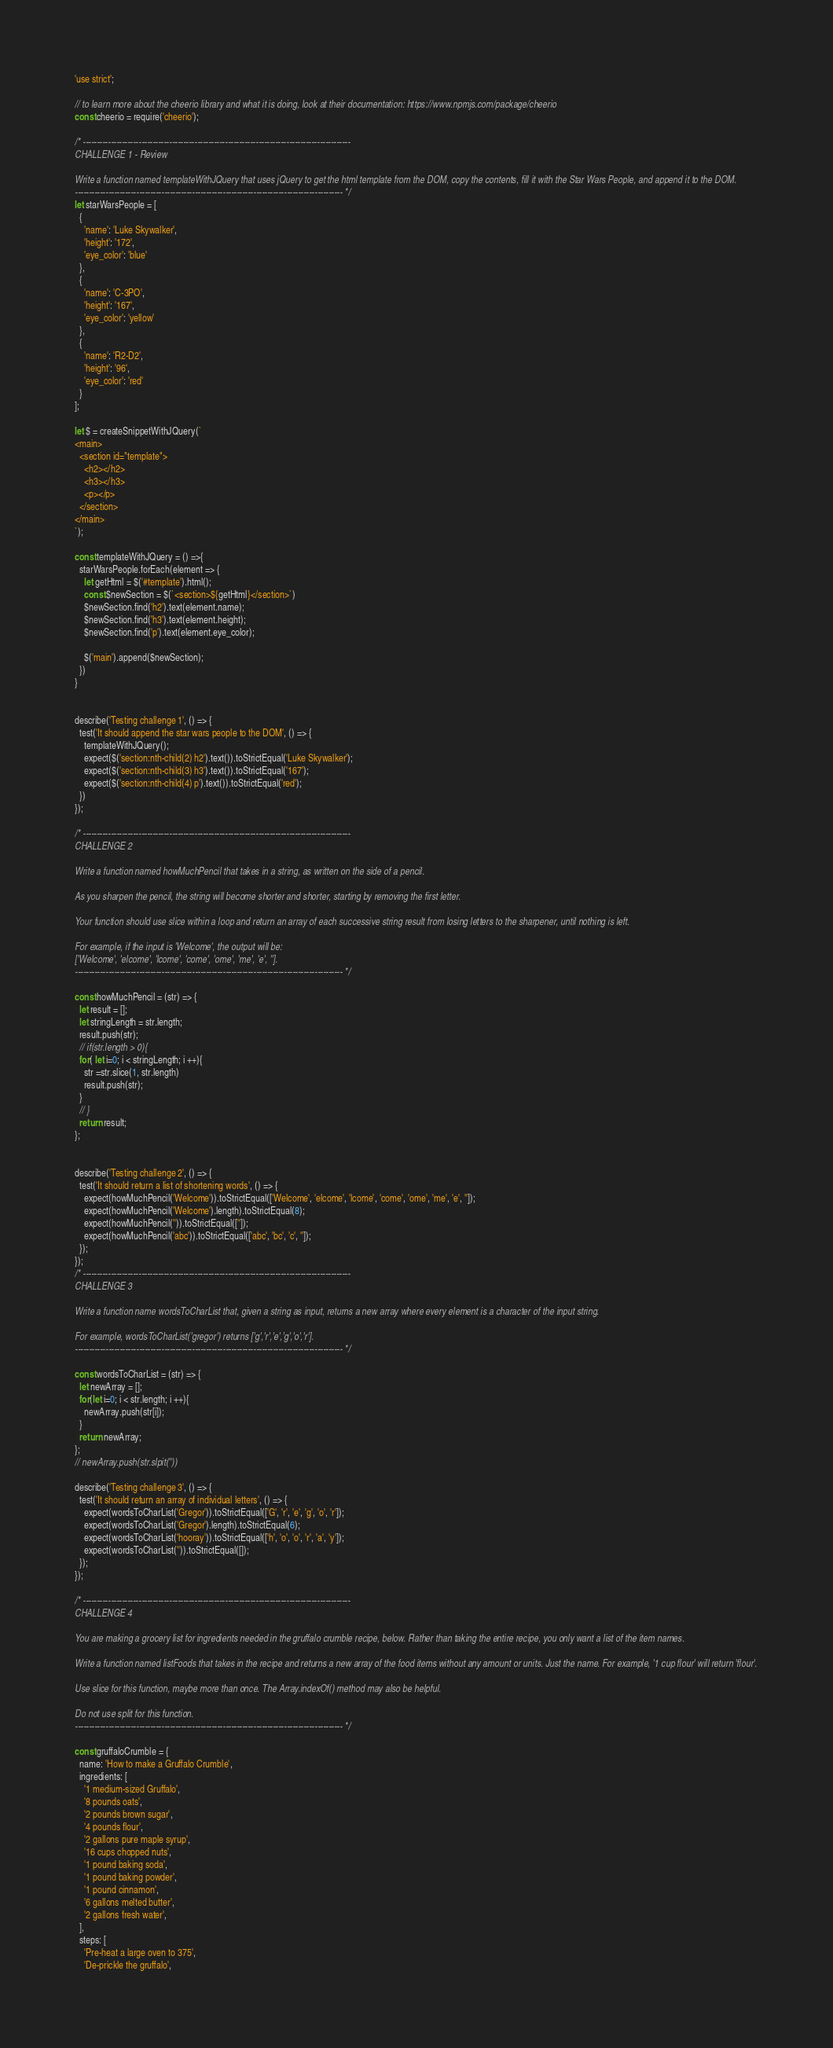<code> <loc_0><loc_0><loc_500><loc_500><_JavaScript_>'use strict';

// to learn more about the cheerio library and what it is doing, look at their documentation: https://www.npmjs.com/package/cheerio
const cheerio = require('cheerio');

/* ------------------------------------------------------------------------------------------------
CHALLENGE 1 - Review

Write a function named templateWithJQuery that uses jQuery to get the html template from the DOM, copy the contents, fill it with the Star Wars People, and append it to the DOM.
------------------------------------------------------------------------------------------------ */
let starWarsPeople = [
  {
    'name': 'Luke Skywalker',
    'height': '172',
    'eye_color': 'blue'
  },
  {
    'name': 'C-3PO',
    'height': '167',
    'eye_color': 'yellow'
  },
  {
    'name': 'R2-D2',
    'height': '96',
    'eye_color': 'red'
  }
];

let $ = createSnippetWithJQuery(`
<main>
  <section id="template">
    <h2></h2>
    <h3></h3>
    <p></p>
  </section>
</main>
`);

const templateWithJQuery = () =>{
  starWarsPeople.forEach(element => {
    let getHtml = $('#template').html();
    const $newSection = $(`<section>${getHtml}</section>`)
    $newSection.find('h2').text(element.name);
    $newSection.find('h3').text(element.height);
    $newSection.find('p').text(element.eye_color);

    $('main').append($newSection);
  })
}


describe('Testing challenge 1', () => {
  test('It should append the star wars people to the DOM', () => {
    templateWithJQuery();
    expect($('section:nth-child(2) h2').text()).toStrictEqual('Luke Skywalker');
    expect($('section:nth-child(3) h3').text()).toStrictEqual('167');
    expect($('section:nth-child(4) p').text()).toStrictEqual('red');
  })
});

/* ------------------------------------------------------------------------------------------------
CHALLENGE 2

Write a function named howMuchPencil that takes in a string, as written on the side of a pencil.

As you sharpen the pencil, the string will become shorter and shorter, starting by removing the first letter.

Your function should use slice within a loop and return an array of each successive string result from losing letters to the sharpener, until nothing is left.

For example, if the input is 'Welcome', the output will be:
['Welcome', 'elcome', 'lcome', 'come', 'ome', 'me', 'e', ''].
------------------------------------------------------------------------------------------------ */

const howMuchPencil = (str) => {
  let result = [];
  let stringLength = str.length;
  result.push(str);
  // if(str.length > 0){
  for( let i=0; i < stringLength; i ++){
    str =str.slice(1, str.length)
    result.push(str);
  }
  // }
  return result;
};


describe('Testing challenge 2', () => {
  test('It should return a list of shortening words', () => {
    expect(howMuchPencil('Welcome')).toStrictEqual(['Welcome', 'elcome', 'lcome', 'come', 'ome', 'me', 'e', '']);
    expect(howMuchPencil('Welcome').length).toStrictEqual(8);
    expect(howMuchPencil('')).toStrictEqual(['']);
    expect(howMuchPencil('abc')).toStrictEqual(['abc', 'bc', 'c', '']);
  });
});
/* ------------------------------------------------------------------------------------------------
CHALLENGE 3

Write a function name wordsToCharList that, given a string as input, returns a new array where every element is a character of the input string.

For example, wordsToCharList('gregor') returns ['g','r','e','g','o','r'].
------------------------------------------------------------------------------------------------ */

const wordsToCharList = (str) => {
  let newArray = [];
  for(let i=0; i < str.length; i ++){
    newArray.push(str[i]);
  }
  return newArray;
};
// newArray.push(str.slpit(''))

describe('Testing challenge 3', () => {
  test('It should return an array of individual letters', () => {
    expect(wordsToCharList('Gregor')).toStrictEqual(['G', 'r', 'e', 'g', 'o', 'r']);
    expect(wordsToCharList('Gregor').length).toStrictEqual(6);
    expect(wordsToCharList('hooray')).toStrictEqual(['h', 'o', 'o', 'r', 'a', 'y']);
    expect(wordsToCharList('')).toStrictEqual([]);
  });
});

/* ------------------------------------------------------------------------------------------------
CHALLENGE 4

You are making a grocery list for ingredients needed in the gruffalo crumble recipe, below. Rather than taking the entire recipe, you only want a list of the item names.

Write a function named listFoods that takes in the recipe and returns a new array of the food items without any amount or units. Just the name. For example, '1 cup flour' will return 'flour'.

Use slice for this function, maybe more than once. The Array.indexOf() method may also be helpful.

Do not use split for this function.
------------------------------------------------------------------------------------------------ */

const gruffaloCrumble = {
  name: 'How to make a Gruffalo Crumble',
  ingredients: [
    '1 medium-sized Gruffalo',
    '8 pounds oats',
    '2 pounds brown sugar',
    '4 pounds flour',
    '2 gallons pure maple syrup',
    '16 cups chopped nuts',
    '1 pound baking soda',
    '1 pound baking powder',
    '1 pound cinnamon',
    '6 gallons melted butter',
    '2 gallons fresh water',
  ],
  steps: [
    'Pre-heat a large oven to 375',
    'De-prickle the gruffalo',</code> 